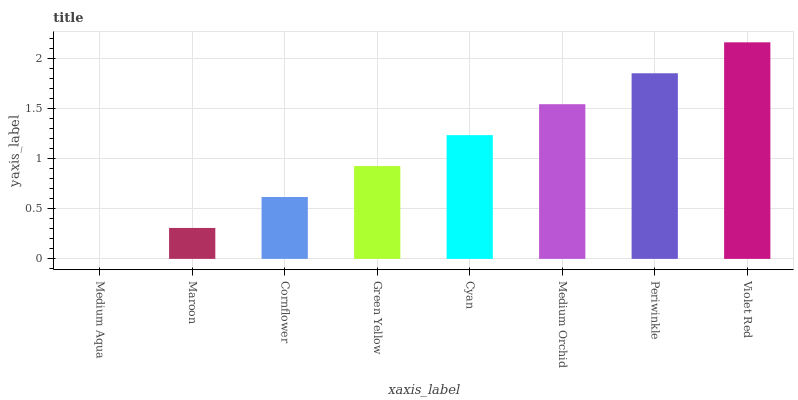Is Medium Aqua the minimum?
Answer yes or no. Yes. Is Violet Red the maximum?
Answer yes or no. Yes. Is Maroon the minimum?
Answer yes or no. No. Is Maroon the maximum?
Answer yes or no. No. Is Maroon greater than Medium Aqua?
Answer yes or no. Yes. Is Medium Aqua less than Maroon?
Answer yes or no. Yes. Is Medium Aqua greater than Maroon?
Answer yes or no. No. Is Maroon less than Medium Aqua?
Answer yes or no. No. Is Cyan the high median?
Answer yes or no. Yes. Is Green Yellow the low median?
Answer yes or no. Yes. Is Medium Orchid the high median?
Answer yes or no. No. Is Periwinkle the low median?
Answer yes or no. No. 